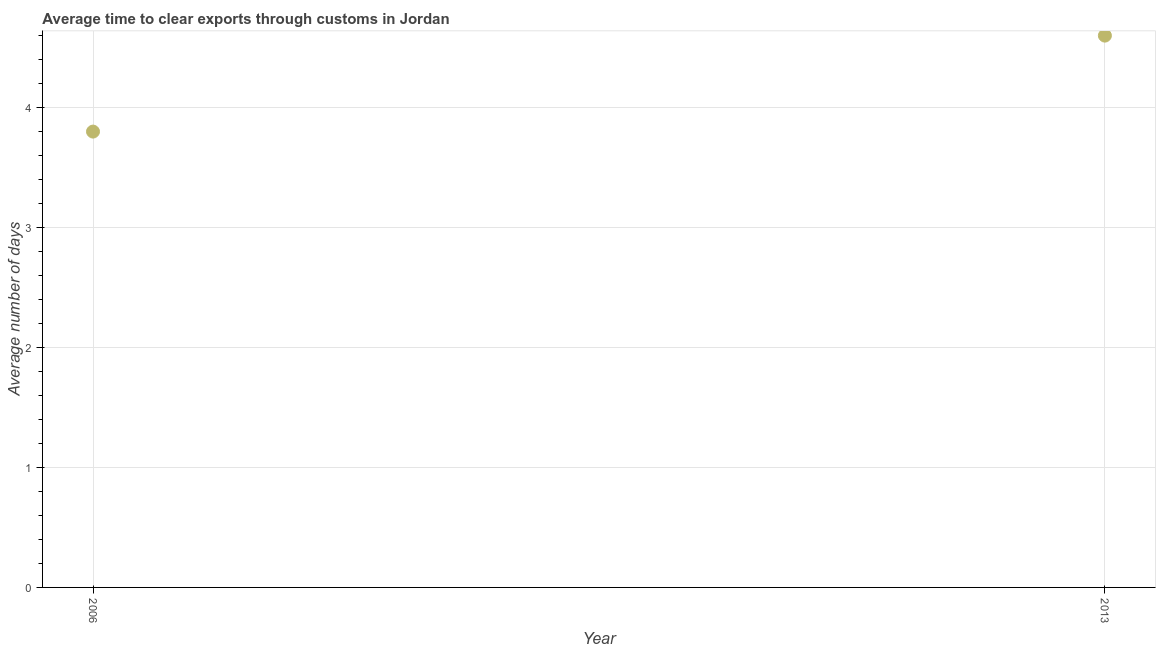Across all years, what is the maximum time to clear exports through customs?
Provide a short and direct response. 4.6. Across all years, what is the minimum time to clear exports through customs?
Your answer should be very brief. 3.8. In which year was the time to clear exports through customs maximum?
Your response must be concise. 2013. What is the sum of the time to clear exports through customs?
Your answer should be compact. 8.4. What is the difference between the time to clear exports through customs in 2006 and 2013?
Your answer should be very brief. -0.8. What is the average time to clear exports through customs per year?
Your answer should be very brief. 4.2. What is the median time to clear exports through customs?
Keep it short and to the point. 4.2. In how many years, is the time to clear exports through customs greater than 2.8 days?
Give a very brief answer. 2. Do a majority of the years between 2006 and 2013 (inclusive) have time to clear exports through customs greater than 2.6 days?
Offer a terse response. Yes. What is the ratio of the time to clear exports through customs in 2006 to that in 2013?
Keep it short and to the point. 0.83. Is the time to clear exports through customs in 2006 less than that in 2013?
Provide a short and direct response. Yes. In how many years, is the time to clear exports through customs greater than the average time to clear exports through customs taken over all years?
Ensure brevity in your answer.  1. How many years are there in the graph?
Offer a terse response. 2. Are the values on the major ticks of Y-axis written in scientific E-notation?
Your answer should be very brief. No. What is the title of the graph?
Give a very brief answer. Average time to clear exports through customs in Jordan. What is the label or title of the X-axis?
Your answer should be very brief. Year. What is the label or title of the Y-axis?
Your answer should be very brief. Average number of days. What is the Average number of days in 2006?
Offer a terse response. 3.8. What is the Average number of days in 2013?
Provide a short and direct response. 4.6. What is the difference between the Average number of days in 2006 and 2013?
Your response must be concise. -0.8. What is the ratio of the Average number of days in 2006 to that in 2013?
Provide a succinct answer. 0.83. 